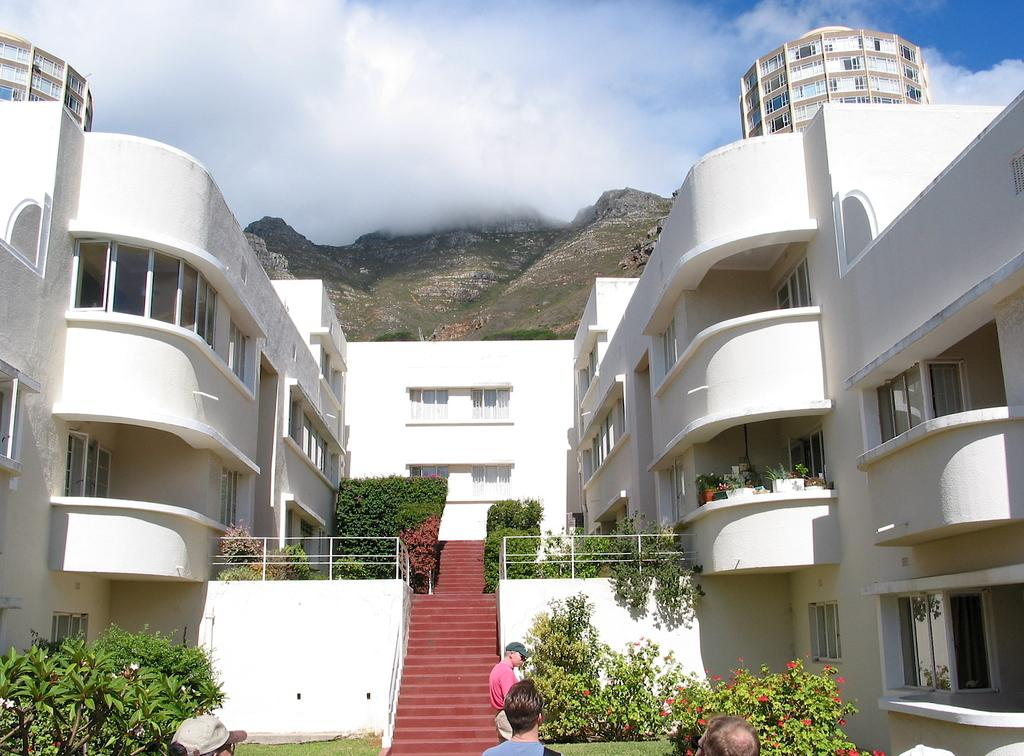How many persons are in the image? There are persons in the image. What other elements can be seen in the image besides the persons? There are buildings, plants, and mountains visible in the image. What is visible in the sky at the top of the image? There are clouds in the sky at the top of the image. What type of bubble can be seen floating near the persons in the image? There is no bubble present in the image. What kind of apparel are the persons wearing in the image? The provided facts do not mention the apparel worn by the persons in the image. 